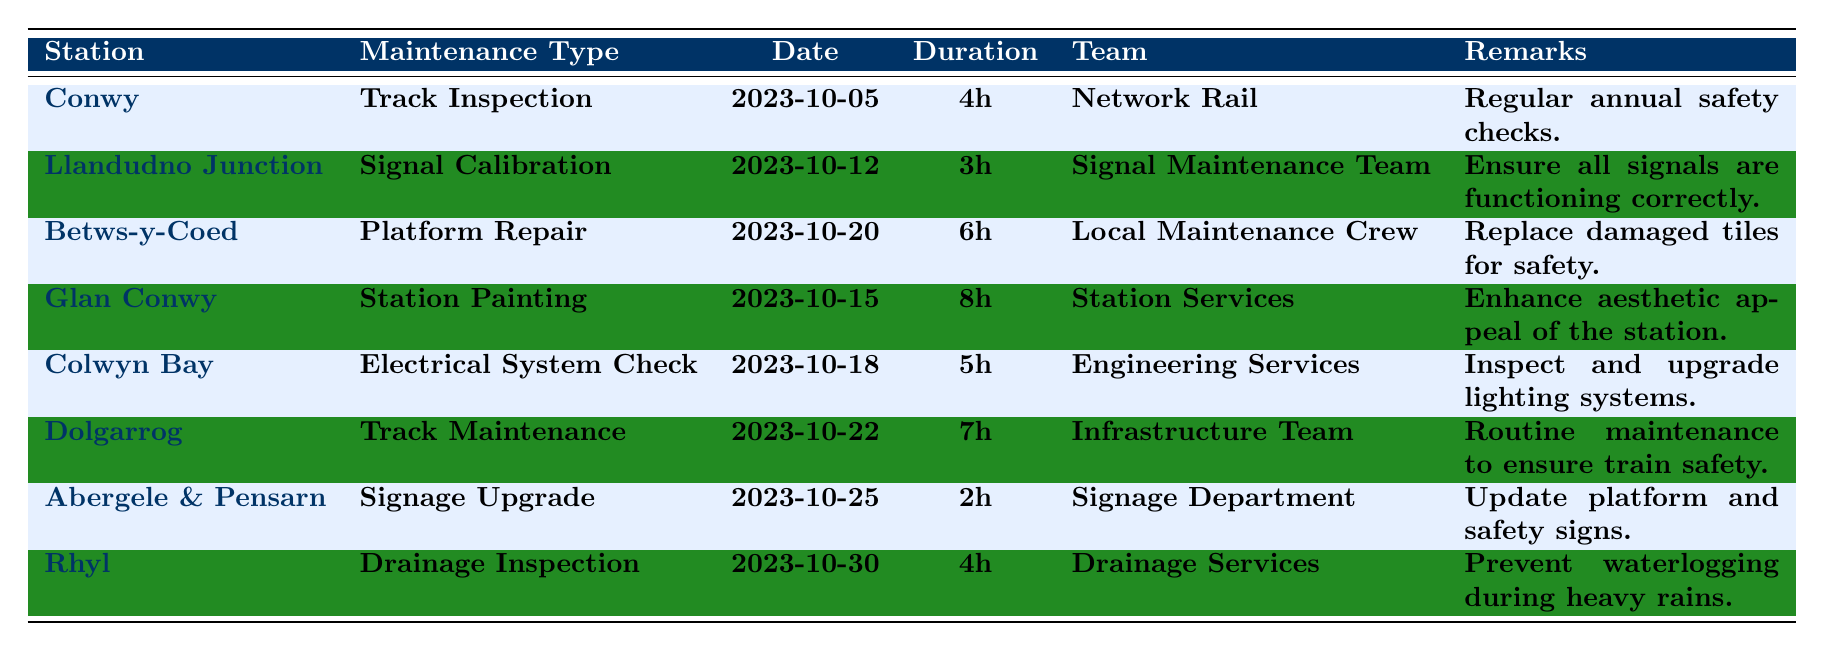What is the scheduled maintenance type for Conwy station? The table shows that the maintenance type for Conwy station is Track Inspection.
Answer: Track Inspection When is the maintenance for Llandudno Junction scheduled? The table indicates that the maintenance for Llandudno Junction is scheduled on 2023-10-12.
Answer: 2023-10-12 How long is the maintenance scheduled for Glan Conwy? The duration of maintenance for Glan Conwy is listed as 8 hours in the table.
Answer: 8 hours Which team is responsible for the platform repair at Betws-y-Coed? According to the table, the Local Maintenance Crew is responsible for the platform repair at Betws-y-Coed.
Answer: Local Maintenance Crew How many hours of maintenance are scheduled for Colwyn Bay? The maintenance scheduled for Colwyn Bay is 5 hours, as stated in the table.
Answer: 5 hours What is the longest maintenance duration listed in the schedule? The table shows that the longest maintenance duration is 8 hours for Glan Conwy's Station Painting.
Answer: 8 hours Is there any maintenance scheduled after October 25th? Yes, there is maintenance scheduled on October 30th for Rhyl, as shown in the table.
Answer: Yes How much time in total will be spent on maintenance for Abergele & Pensarn and Rhyl? Abergele & Pensarn has 2 hours scheduled, and Rhyl has 4 hours scheduled. Summing these gives 2 + 4 = 6 hours.
Answer: 6 hours Which station has both the earliest and latest scheduled maintenance? Conwy has the earliest scheduled maintenance on October 5th, and Rhyl has the latest on October 30th, according to the table.
Answer: Conwy and Rhyl How many total hours of maintenance are scheduled across all stations? The total hours can be calculated by adding all durations: 4 + 3 + 6 + 8 + 5 + 7 + 2 + 4 = 39 hours.
Answer: 39 hours What maintenance type is scheduled for Dolgarrog? The maintenance type scheduled for Dolgarrog is Track Maintenance, as noted in the table.
Answer: Track Maintenance Is the Signage Upgrade in Abergele & Pensarn occurring before the Electrical System Check in Colwyn Bay? Yes, the Signage Upgrade on October 25th is scheduled after the Electrical System Check on October 18th, as indicated in the timetable.
Answer: No How many stations have scheduled maintenance involving inspections? The stations with scheduled inspections are Conwy (Track Inspection), Rhyl (Drainage Inspection), and Colwyn Bay (Electrical System Check), totaling 3 stations.
Answer: 3 stations 